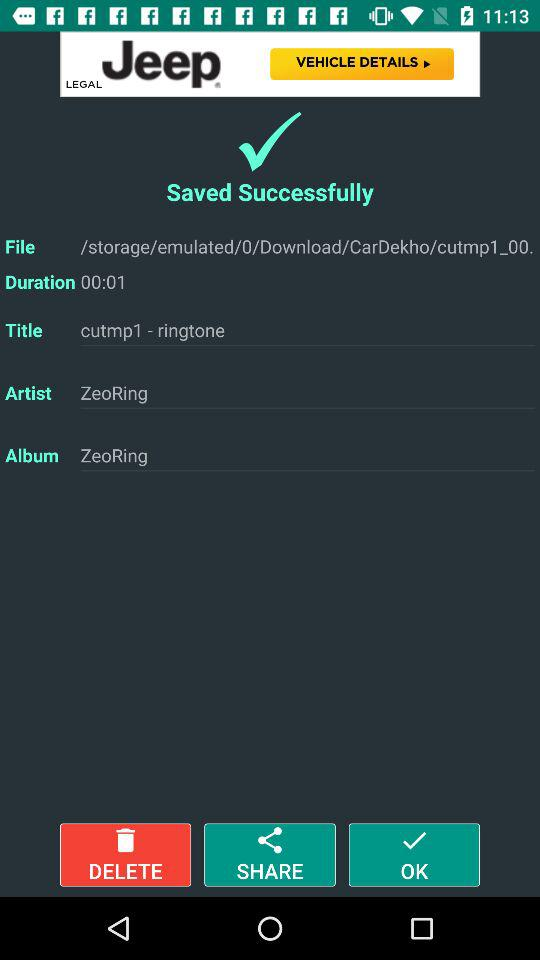What's the artist name? The artist name is "ZeoRing". 